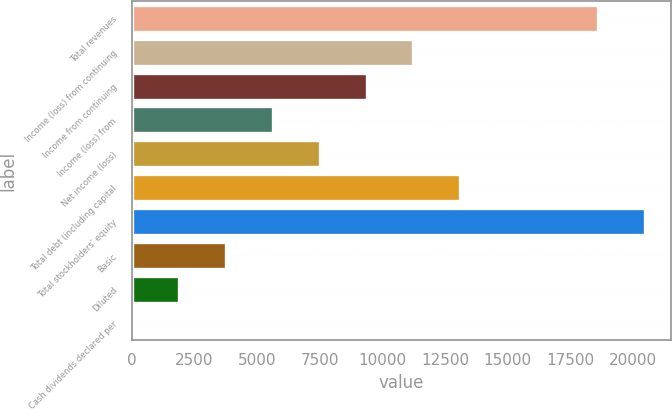<chart> <loc_0><loc_0><loc_500><loc_500><bar_chart><fcel>Total revenues<fcel>Income (loss) from continuing<fcel>Income from continuing<fcel>Income (loss) from<fcel>Net income (loss)<fcel>Total debt (including capital<fcel>Total stockholders' equity<fcel>Basic<fcel>Diluted<fcel>Cash dividends declared per<nl><fcel>18614<fcel>11232.2<fcel>9360.31<fcel>5616.45<fcel>7488.38<fcel>13104.2<fcel>20485.9<fcel>3744.52<fcel>1872.59<fcel>0.66<nl></chart> 